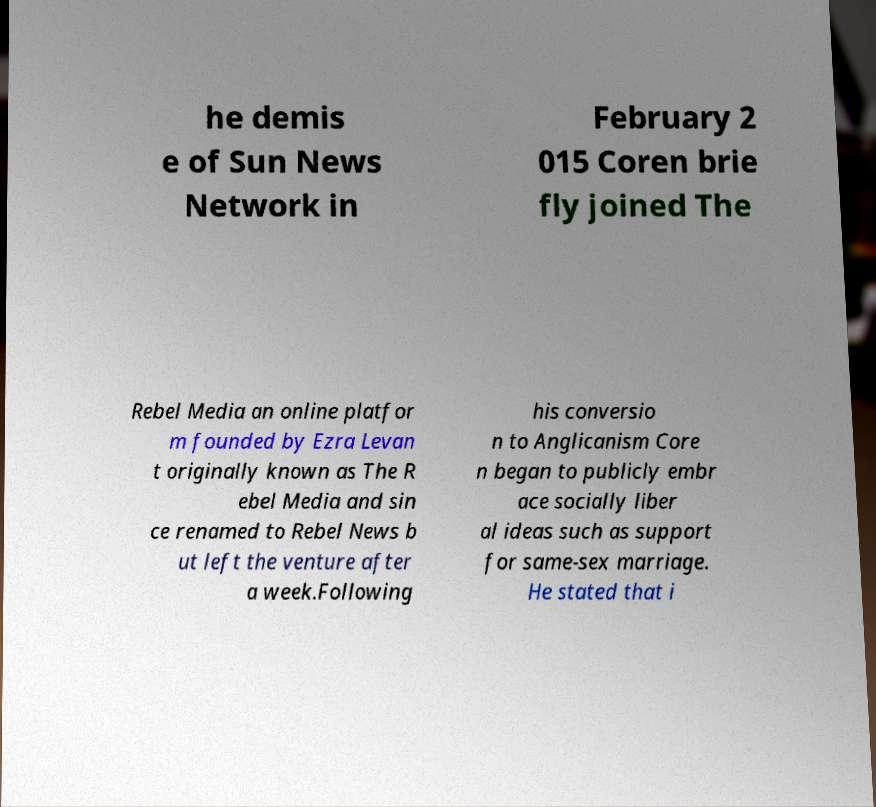Can you read and provide the text displayed in the image?This photo seems to have some interesting text. Can you extract and type it out for me? he demis e of Sun News Network in February 2 015 Coren brie fly joined The Rebel Media an online platfor m founded by Ezra Levan t originally known as The R ebel Media and sin ce renamed to Rebel News b ut left the venture after a week.Following his conversio n to Anglicanism Core n began to publicly embr ace socially liber al ideas such as support for same-sex marriage. He stated that i 